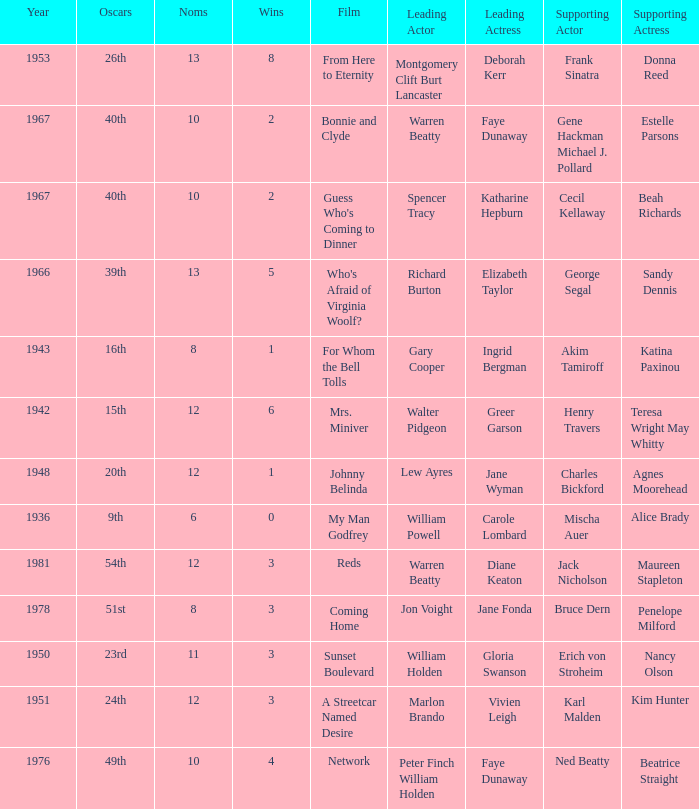Who was the supporting actress in "For Whom the Bell Tolls"? Katina Paxinou. 